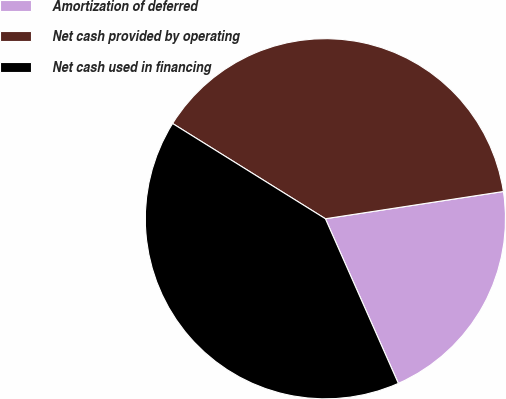<chart> <loc_0><loc_0><loc_500><loc_500><pie_chart><fcel>Amortization of deferred<fcel>Net cash provided by operating<fcel>Net cash used in financing<nl><fcel>20.78%<fcel>38.71%<fcel>40.51%<nl></chart> 